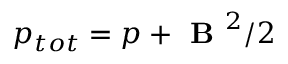<formula> <loc_0><loc_0><loc_500><loc_500>p _ { t o t } = p + B ^ { 2 } / 2</formula> 